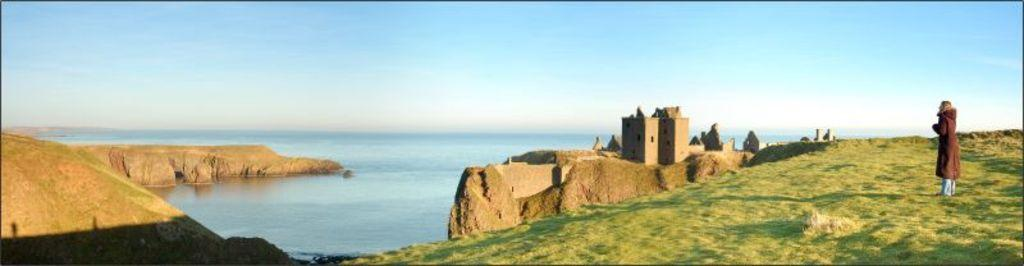Who is present in the image? There is a woman in the image. What is the woman standing on? The woman is standing on the grass. What type of structures can be seen in the image? There are buildings visible in the image. What natural element is visible in the image? There is water visible in the image. What type of books can be seen floating in the water in the image? There are no books visible in the image, and no books are floating in the water. 